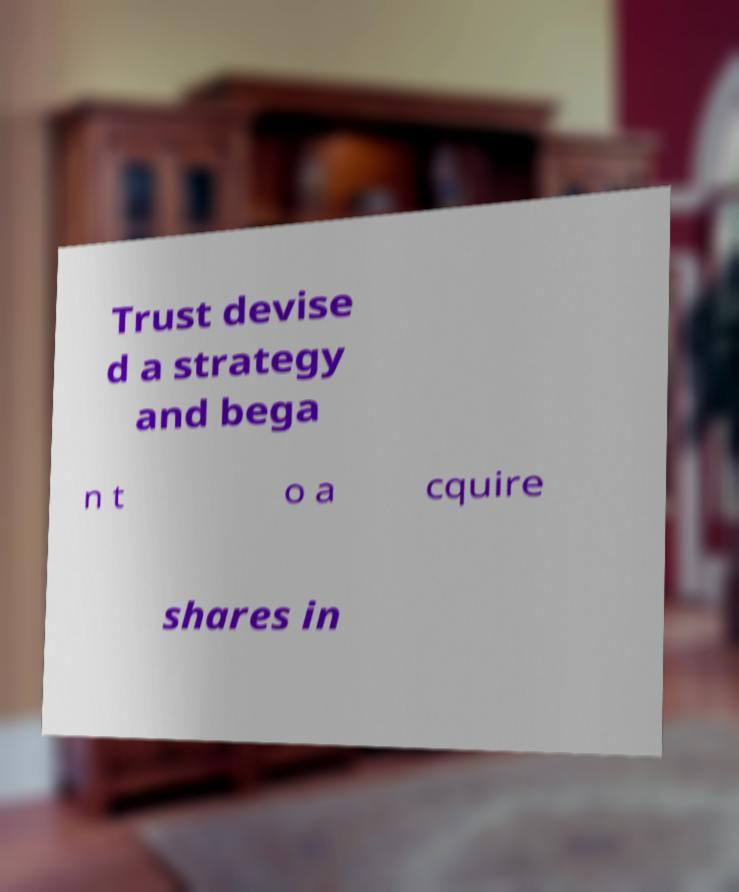Can you accurately transcribe the text from the provided image for me? Trust devise d a strategy and bega n t o a cquire shares in 